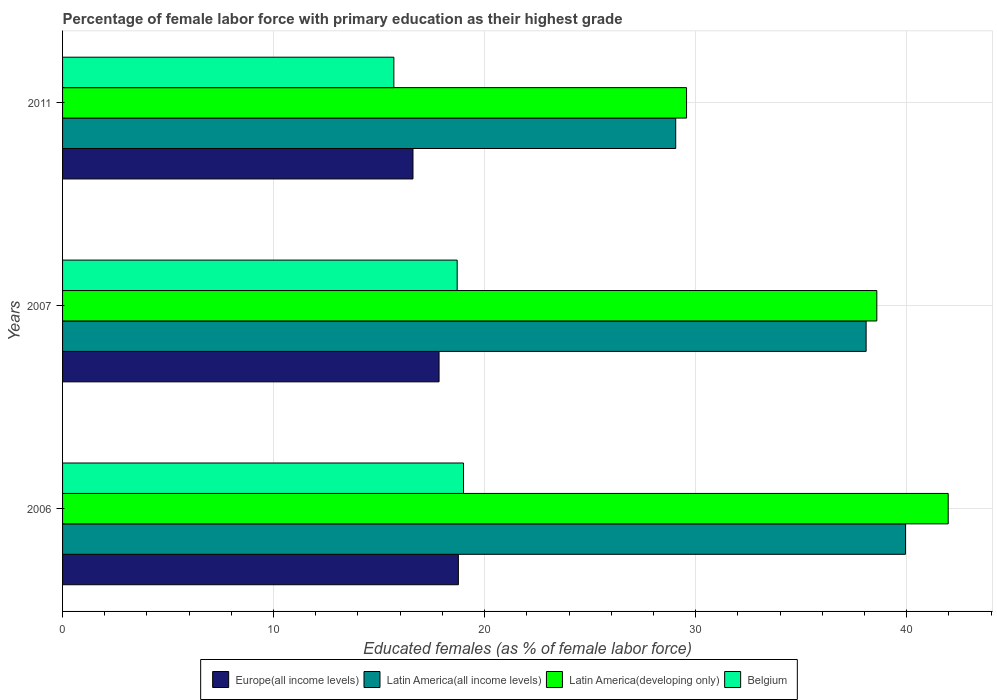How many different coloured bars are there?
Your answer should be very brief. 4. How many groups of bars are there?
Offer a very short reply. 3. What is the percentage of female labor force with primary education in Europe(all income levels) in 2007?
Your answer should be very brief. 17.84. Across all years, what is the maximum percentage of female labor force with primary education in Belgium?
Your response must be concise. 19. Across all years, what is the minimum percentage of female labor force with primary education in Latin America(developing only)?
Your response must be concise. 29.57. In which year was the percentage of female labor force with primary education in Europe(all income levels) maximum?
Your answer should be very brief. 2006. In which year was the percentage of female labor force with primary education in Latin America(all income levels) minimum?
Offer a very short reply. 2011. What is the total percentage of female labor force with primary education in Belgium in the graph?
Make the answer very short. 53.4. What is the difference between the percentage of female labor force with primary education in Europe(all income levels) in 2006 and that in 2011?
Offer a terse response. 2.15. What is the difference between the percentage of female labor force with primary education in Latin America(all income levels) in 2006 and the percentage of female labor force with primary education in Belgium in 2011?
Your response must be concise. 24.25. What is the average percentage of female labor force with primary education in Latin America(developing only) per year?
Provide a succinct answer. 36.71. In the year 2011, what is the difference between the percentage of female labor force with primary education in Europe(all income levels) and percentage of female labor force with primary education in Belgium?
Offer a terse response. 0.91. What is the ratio of the percentage of female labor force with primary education in Europe(all income levels) in 2006 to that in 2011?
Provide a short and direct response. 1.13. Is the difference between the percentage of female labor force with primary education in Europe(all income levels) in 2006 and 2007 greater than the difference between the percentage of female labor force with primary education in Belgium in 2006 and 2007?
Your answer should be compact. Yes. What is the difference between the highest and the second highest percentage of female labor force with primary education in Belgium?
Your answer should be compact. 0.3. What is the difference between the highest and the lowest percentage of female labor force with primary education in Latin America(all income levels)?
Your answer should be compact. 10.89. In how many years, is the percentage of female labor force with primary education in Europe(all income levels) greater than the average percentage of female labor force with primary education in Europe(all income levels) taken over all years?
Your answer should be very brief. 2. What does the 3rd bar from the top in 2006 represents?
Your answer should be very brief. Latin America(all income levels). What does the 1st bar from the bottom in 2007 represents?
Your answer should be very brief. Europe(all income levels). Is it the case that in every year, the sum of the percentage of female labor force with primary education in Latin America(all income levels) and percentage of female labor force with primary education in Europe(all income levels) is greater than the percentage of female labor force with primary education in Belgium?
Provide a short and direct response. Yes. How many bars are there?
Your answer should be very brief. 12. How many years are there in the graph?
Keep it short and to the point. 3. Does the graph contain any zero values?
Give a very brief answer. No. Does the graph contain grids?
Your response must be concise. Yes. Where does the legend appear in the graph?
Offer a terse response. Bottom center. How many legend labels are there?
Offer a very short reply. 4. How are the legend labels stacked?
Keep it short and to the point. Horizontal. What is the title of the graph?
Keep it short and to the point. Percentage of female labor force with primary education as their highest grade. What is the label or title of the X-axis?
Your answer should be very brief. Educated females (as % of female labor force). What is the Educated females (as % of female labor force) in Europe(all income levels) in 2006?
Your answer should be compact. 18.76. What is the Educated females (as % of female labor force) of Latin America(all income levels) in 2006?
Your answer should be very brief. 39.95. What is the Educated females (as % of female labor force) in Latin America(developing only) in 2006?
Keep it short and to the point. 41.97. What is the Educated females (as % of female labor force) of Belgium in 2006?
Your answer should be very brief. 19. What is the Educated females (as % of female labor force) in Europe(all income levels) in 2007?
Ensure brevity in your answer.  17.84. What is the Educated females (as % of female labor force) in Latin America(all income levels) in 2007?
Make the answer very short. 38.08. What is the Educated females (as % of female labor force) in Latin America(developing only) in 2007?
Keep it short and to the point. 38.59. What is the Educated females (as % of female labor force) in Belgium in 2007?
Make the answer very short. 18.7. What is the Educated females (as % of female labor force) in Europe(all income levels) in 2011?
Offer a very short reply. 16.61. What is the Educated females (as % of female labor force) in Latin America(all income levels) in 2011?
Give a very brief answer. 29.06. What is the Educated females (as % of female labor force) in Latin America(developing only) in 2011?
Your answer should be very brief. 29.57. What is the Educated females (as % of female labor force) in Belgium in 2011?
Provide a succinct answer. 15.7. Across all years, what is the maximum Educated females (as % of female labor force) in Europe(all income levels)?
Your answer should be compact. 18.76. Across all years, what is the maximum Educated females (as % of female labor force) in Latin America(all income levels)?
Your response must be concise. 39.95. Across all years, what is the maximum Educated females (as % of female labor force) of Latin America(developing only)?
Provide a short and direct response. 41.97. Across all years, what is the minimum Educated females (as % of female labor force) of Europe(all income levels)?
Your answer should be very brief. 16.61. Across all years, what is the minimum Educated females (as % of female labor force) of Latin America(all income levels)?
Offer a very short reply. 29.06. Across all years, what is the minimum Educated females (as % of female labor force) in Latin America(developing only)?
Provide a short and direct response. 29.57. Across all years, what is the minimum Educated females (as % of female labor force) in Belgium?
Offer a terse response. 15.7. What is the total Educated females (as % of female labor force) of Europe(all income levels) in the graph?
Provide a succinct answer. 53.21. What is the total Educated females (as % of female labor force) of Latin America(all income levels) in the graph?
Your answer should be compact. 107.08. What is the total Educated females (as % of female labor force) in Latin America(developing only) in the graph?
Keep it short and to the point. 110.13. What is the total Educated females (as % of female labor force) in Belgium in the graph?
Keep it short and to the point. 53.4. What is the difference between the Educated females (as % of female labor force) of Europe(all income levels) in 2006 and that in 2007?
Ensure brevity in your answer.  0.92. What is the difference between the Educated females (as % of female labor force) in Latin America(all income levels) in 2006 and that in 2007?
Offer a very short reply. 1.87. What is the difference between the Educated females (as % of female labor force) in Latin America(developing only) in 2006 and that in 2007?
Your answer should be compact. 3.38. What is the difference between the Educated females (as % of female labor force) in Europe(all income levels) in 2006 and that in 2011?
Your answer should be very brief. 2.15. What is the difference between the Educated females (as % of female labor force) in Latin America(all income levels) in 2006 and that in 2011?
Offer a terse response. 10.89. What is the difference between the Educated females (as % of female labor force) in Latin America(developing only) in 2006 and that in 2011?
Your response must be concise. 12.4. What is the difference between the Educated females (as % of female labor force) of Belgium in 2006 and that in 2011?
Make the answer very short. 3.3. What is the difference between the Educated females (as % of female labor force) of Europe(all income levels) in 2007 and that in 2011?
Make the answer very short. 1.24. What is the difference between the Educated females (as % of female labor force) of Latin America(all income levels) in 2007 and that in 2011?
Provide a short and direct response. 9.02. What is the difference between the Educated females (as % of female labor force) in Latin America(developing only) in 2007 and that in 2011?
Offer a very short reply. 9.02. What is the difference between the Educated females (as % of female labor force) in Belgium in 2007 and that in 2011?
Offer a very short reply. 3. What is the difference between the Educated females (as % of female labor force) in Europe(all income levels) in 2006 and the Educated females (as % of female labor force) in Latin America(all income levels) in 2007?
Your answer should be very brief. -19.32. What is the difference between the Educated females (as % of female labor force) of Europe(all income levels) in 2006 and the Educated females (as % of female labor force) of Latin America(developing only) in 2007?
Keep it short and to the point. -19.83. What is the difference between the Educated females (as % of female labor force) in Europe(all income levels) in 2006 and the Educated females (as % of female labor force) in Belgium in 2007?
Your answer should be very brief. 0.06. What is the difference between the Educated females (as % of female labor force) in Latin America(all income levels) in 2006 and the Educated females (as % of female labor force) in Latin America(developing only) in 2007?
Give a very brief answer. 1.36. What is the difference between the Educated females (as % of female labor force) of Latin America(all income levels) in 2006 and the Educated females (as % of female labor force) of Belgium in 2007?
Your answer should be very brief. 21.25. What is the difference between the Educated females (as % of female labor force) of Latin America(developing only) in 2006 and the Educated females (as % of female labor force) of Belgium in 2007?
Offer a very short reply. 23.27. What is the difference between the Educated females (as % of female labor force) of Europe(all income levels) in 2006 and the Educated females (as % of female labor force) of Latin America(all income levels) in 2011?
Your response must be concise. -10.3. What is the difference between the Educated females (as % of female labor force) in Europe(all income levels) in 2006 and the Educated females (as % of female labor force) in Latin America(developing only) in 2011?
Offer a terse response. -10.81. What is the difference between the Educated females (as % of female labor force) in Europe(all income levels) in 2006 and the Educated females (as % of female labor force) in Belgium in 2011?
Your answer should be compact. 3.06. What is the difference between the Educated females (as % of female labor force) in Latin America(all income levels) in 2006 and the Educated females (as % of female labor force) in Latin America(developing only) in 2011?
Make the answer very short. 10.38. What is the difference between the Educated females (as % of female labor force) of Latin America(all income levels) in 2006 and the Educated females (as % of female labor force) of Belgium in 2011?
Keep it short and to the point. 24.25. What is the difference between the Educated females (as % of female labor force) in Latin America(developing only) in 2006 and the Educated females (as % of female labor force) in Belgium in 2011?
Offer a terse response. 26.27. What is the difference between the Educated females (as % of female labor force) of Europe(all income levels) in 2007 and the Educated females (as % of female labor force) of Latin America(all income levels) in 2011?
Provide a succinct answer. -11.21. What is the difference between the Educated females (as % of female labor force) of Europe(all income levels) in 2007 and the Educated females (as % of female labor force) of Latin America(developing only) in 2011?
Make the answer very short. -11.73. What is the difference between the Educated females (as % of female labor force) in Europe(all income levels) in 2007 and the Educated females (as % of female labor force) in Belgium in 2011?
Provide a succinct answer. 2.14. What is the difference between the Educated females (as % of female labor force) of Latin America(all income levels) in 2007 and the Educated females (as % of female labor force) of Latin America(developing only) in 2011?
Provide a succinct answer. 8.51. What is the difference between the Educated females (as % of female labor force) in Latin America(all income levels) in 2007 and the Educated females (as % of female labor force) in Belgium in 2011?
Give a very brief answer. 22.38. What is the difference between the Educated females (as % of female labor force) of Latin America(developing only) in 2007 and the Educated females (as % of female labor force) of Belgium in 2011?
Make the answer very short. 22.89. What is the average Educated females (as % of female labor force) of Europe(all income levels) per year?
Provide a succinct answer. 17.74. What is the average Educated females (as % of female labor force) in Latin America(all income levels) per year?
Your answer should be compact. 35.69. What is the average Educated females (as % of female labor force) in Latin America(developing only) per year?
Give a very brief answer. 36.71. In the year 2006, what is the difference between the Educated females (as % of female labor force) in Europe(all income levels) and Educated females (as % of female labor force) in Latin America(all income levels)?
Provide a succinct answer. -21.19. In the year 2006, what is the difference between the Educated females (as % of female labor force) of Europe(all income levels) and Educated females (as % of female labor force) of Latin America(developing only)?
Provide a short and direct response. -23.21. In the year 2006, what is the difference between the Educated females (as % of female labor force) in Europe(all income levels) and Educated females (as % of female labor force) in Belgium?
Make the answer very short. -0.24. In the year 2006, what is the difference between the Educated females (as % of female labor force) of Latin America(all income levels) and Educated females (as % of female labor force) of Latin America(developing only)?
Provide a short and direct response. -2.02. In the year 2006, what is the difference between the Educated females (as % of female labor force) of Latin America(all income levels) and Educated females (as % of female labor force) of Belgium?
Give a very brief answer. 20.95. In the year 2006, what is the difference between the Educated females (as % of female labor force) of Latin America(developing only) and Educated females (as % of female labor force) of Belgium?
Your answer should be compact. 22.97. In the year 2007, what is the difference between the Educated females (as % of female labor force) of Europe(all income levels) and Educated females (as % of female labor force) of Latin America(all income levels)?
Keep it short and to the point. -20.24. In the year 2007, what is the difference between the Educated females (as % of female labor force) in Europe(all income levels) and Educated females (as % of female labor force) in Latin America(developing only)?
Offer a terse response. -20.74. In the year 2007, what is the difference between the Educated females (as % of female labor force) in Europe(all income levels) and Educated females (as % of female labor force) in Belgium?
Offer a terse response. -0.86. In the year 2007, what is the difference between the Educated females (as % of female labor force) of Latin America(all income levels) and Educated females (as % of female labor force) of Latin America(developing only)?
Give a very brief answer. -0.51. In the year 2007, what is the difference between the Educated females (as % of female labor force) in Latin America(all income levels) and Educated females (as % of female labor force) in Belgium?
Give a very brief answer. 19.38. In the year 2007, what is the difference between the Educated females (as % of female labor force) of Latin America(developing only) and Educated females (as % of female labor force) of Belgium?
Give a very brief answer. 19.89. In the year 2011, what is the difference between the Educated females (as % of female labor force) in Europe(all income levels) and Educated females (as % of female labor force) in Latin America(all income levels)?
Your answer should be compact. -12.45. In the year 2011, what is the difference between the Educated females (as % of female labor force) of Europe(all income levels) and Educated females (as % of female labor force) of Latin America(developing only)?
Offer a very short reply. -12.96. In the year 2011, what is the difference between the Educated females (as % of female labor force) of Europe(all income levels) and Educated females (as % of female labor force) of Belgium?
Your answer should be compact. 0.91. In the year 2011, what is the difference between the Educated females (as % of female labor force) in Latin America(all income levels) and Educated females (as % of female labor force) in Latin America(developing only)?
Your response must be concise. -0.51. In the year 2011, what is the difference between the Educated females (as % of female labor force) in Latin America(all income levels) and Educated females (as % of female labor force) in Belgium?
Your answer should be compact. 13.36. In the year 2011, what is the difference between the Educated females (as % of female labor force) in Latin America(developing only) and Educated females (as % of female labor force) in Belgium?
Your answer should be compact. 13.87. What is the ratio of the Educated females (as % of female labor force) of Europe(all income levels) in 2006 to that in 2007?
Ensure brevity in your answer.  1.05. What is the ratio of the Educated females (as % of female labor force) in Latin America(all income levels) in 2006 to that in 2007?
Provide a succinct answer. 1.05. What is the ratio of the Educated females (as % of female labor force) of Latin America(developing only) in 2006 to that in 2007?
Your answer should be compact. 1.09. What is the ratio of the Educated females (as % of female labor force) of Europe(all income levels) in 2006 to that in 2011?
Make the answer very short. 1.13. What is the ratio of the Educated females (as % of female labor force) of Latin America(all income levels) in 2006 to that in 2011?
Your response must be concise. 1.37. What is the ratio of the Educated females (as % of female labor force) in Latin America(developing only) in 2006 to that in 2011?
Offer a terse response. 1.42. What is the ratio of the Educated females (as % of female labor force) in Belgium in 2006 to that in 2011?
Your response must be concise. 1.21. What is the ratio of the Educated females (as % of female labor force) of Europe(all income levels) in 2007 to that in 2011?
Offer a terse response. 1.07. What is the ratio of the Educated females (as % of female labor force) in Latin America(all income levels) in 2007 to that in 2011?
Provide a short and direct response. 1.31. What is the ratio of the Educated females (as % of female labor force) of Latin America(developing only) in 2007 to that in 2011?
Provide a short and direct response. 1.3. What is the ratio of the Educated females (as % of female labor force) of Belgium in 2007 to that in 2011?
Your answer should be very brief. 1.19. What is the difference between the highest and the second highest Educated females (as % of female labor force) in Europe(all income levels)?
Your answer should be very brief. 0.92. What is the difference between the highest and the second highest Educated females (as % of female labor force) in Latin America(all income levels)?
Make the answer very short. 1.87. What is the difference between the highest and the second highest Educated females (as % of female labor force) of Latin America(developing only)?
Keep it short and to the point. 3.38. What is the difference between the highest and the lowest Educated females (as % of female labor force) in Europe(all income levels)?
Your response must be concise. 2.15. What is the difference between the highest and the lowest Educated females (as % of female labor force) of Latin America(all income levels)?
Make the answer very short. 10.89. What is the difference between the highest and the lowest Educated females (as % of female labor force) of Latin America(developing only)?
Provide a short and direct response. 12.4. 